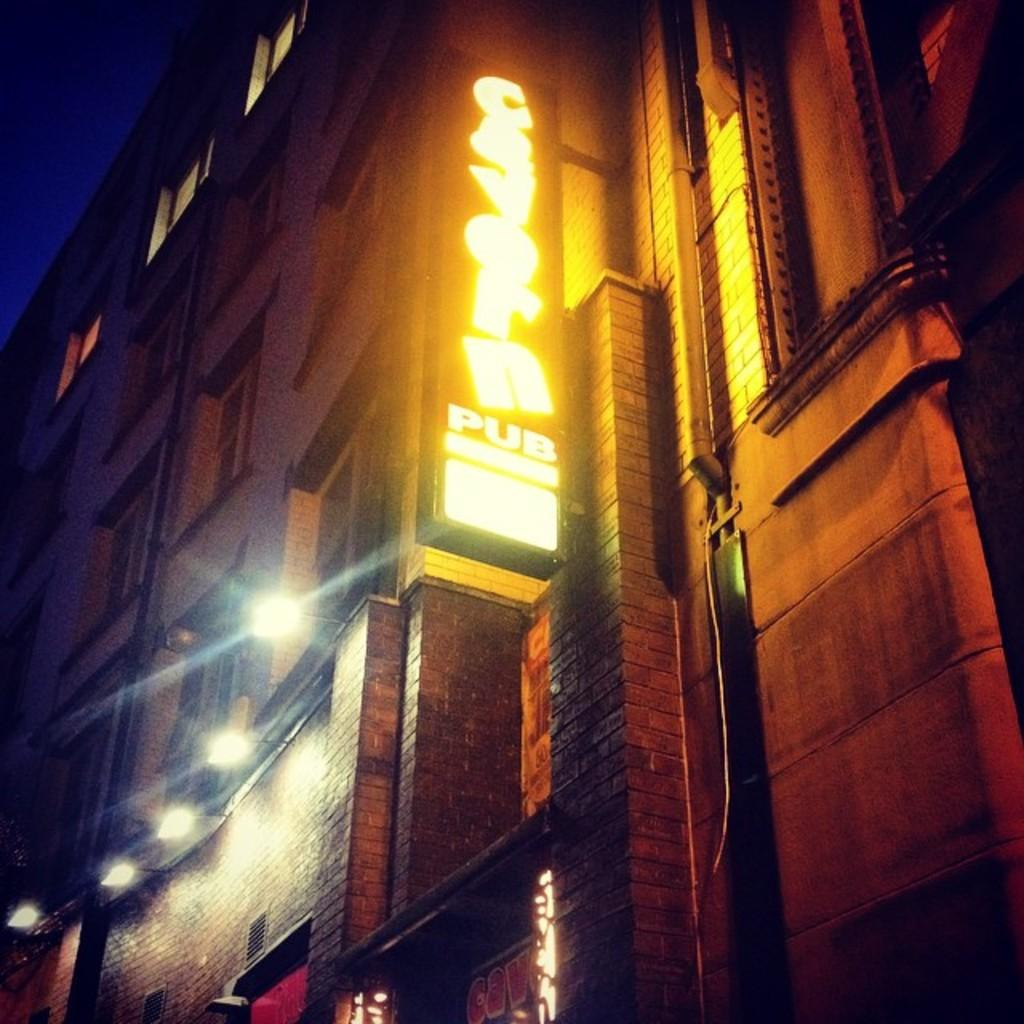What is the main subject in the center of the image? There is a building in the center of the image. What else can be seen in the image besides the building? There are lights visible in the image. Is there any text or information displayed in the image? Yes, there is a board with some text in the image. How many fish can be seen swimming around the building in the image? There are no fish present in the image; it features a building with lights and a board with text. 